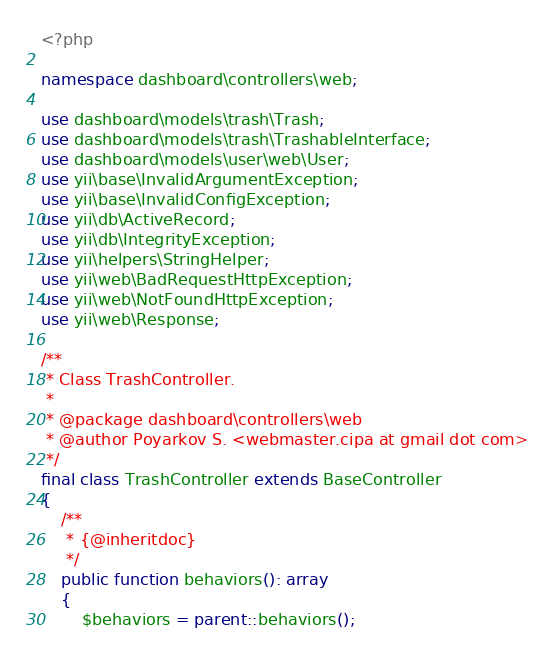Convert code to text. <code><loc_0><loc_0><loc_500><loc_500><_PHP_><?php

namespace dashboard\controllers\web;

use dashboard\models\trash\Trash;
use dashboard\models\trash\TrashableInterface;
use dashboard\models\user\web\User;
use yii\base\InvalidArgumentException;
use yii\base\InvalidConfigException;
use yii\db\ActiveRecord;
use yii\db\IntegrityException;
use yii\helpers\StringHelper;
use yii\web\BadRequestHttpException;
use yii\web\NotFoundHttpException;
use yii\web\Response;

/**
 * Class TrashController.
 *
 * @package dashboard\controllers\web
 * @author Poyarkov S. <webmaster.cipa at gmail dot com>
 */
final class TrashController extends BaseController
{
    /**
     * {@inheritdoc}
     */
    public function behaviors(): array
    {
        $behaviors = parent::behaviors();
</code> 